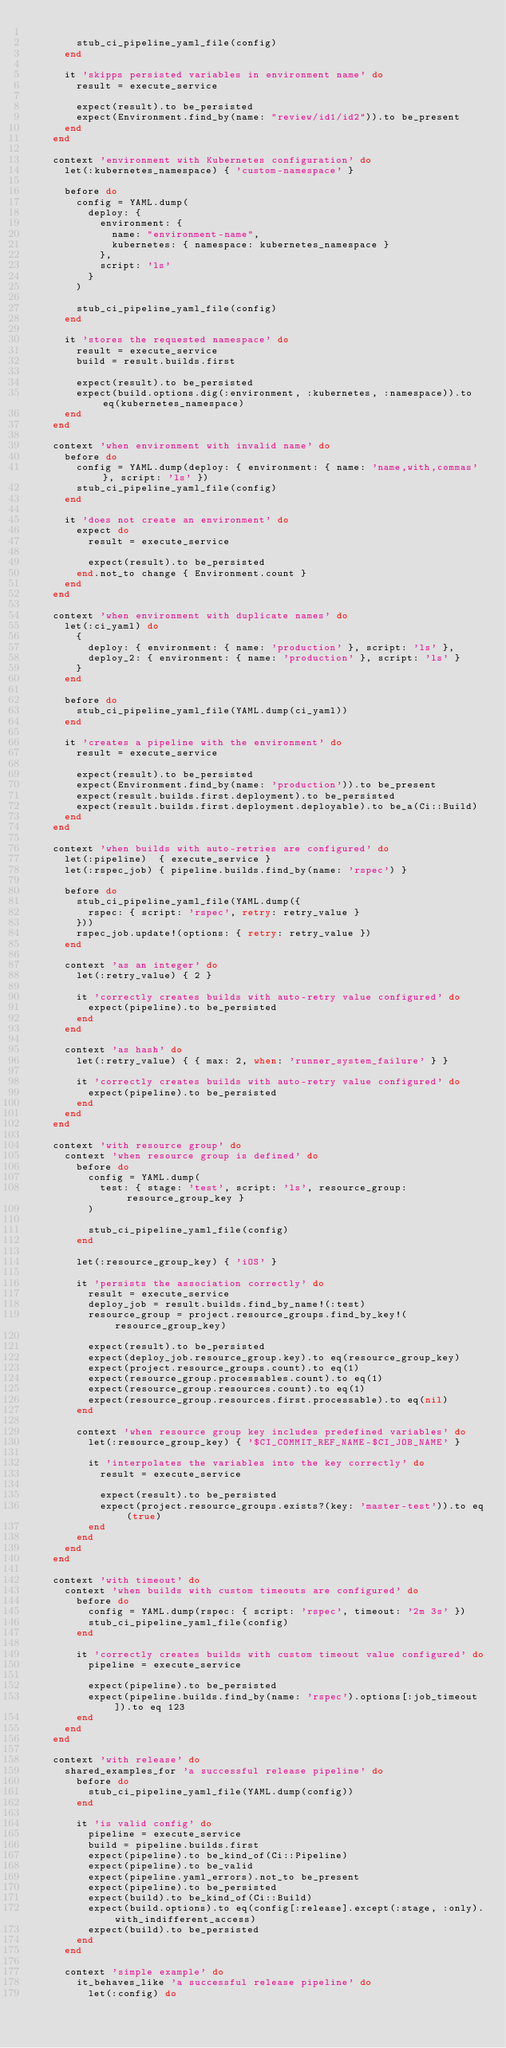<code> <loc_0><loc_0><loc_500><loc_500><_Ruby_>
        stub_ci_pipeline_yaml_file(config)
      end

      it 'skipps persisted variables in environment name' do
        result = execute_service

        expect(result).to be_persisted
        expect(Environment.find_by(name: "review/id1/id2")).to be_present
      end
    end

    context 'environment with Kubernetes configuration' do
      let(:kubernetes_namespace) { 'custom-namespace' }

      before do
        config = YAML.dump(
          deploy: {
            environment: {
              name: "environment-name",
              kubernetes: { namespace: kubernetes_namespace }
            },
            script: 'ls'
          }
        )

        stub_ci_pipeline_yaml_file(config)
      end

      it 'stores the requested namespace' do
        result = execute_service
        build = result.builds.first

        expect(result).to be_persisted
        expect(build.options.dig(:environment, :kubernetes, :namespace)).to eq(kubernetes_namespace)
      end
    end

    context 'when environment with invalid name' do
      before do
        config = YAML.dump(deploy: { environment: { name: 'name,with,commas' }, script: 'ls' })
        stub_ci_pipeline_yaml_file(config)
      end

      it 'does not create an environment' do
        expect do
          result = execute_service

          expect(result).to be_persisted
        end.not_to change { Environment.count }
      end
    end

    context 'when environment with duplicate names' do
      let(:ci_yaml) do
        {
          deploy: { environment: { name: 'production' }, script: 'ls' },
          deploy_2: { environment: { name: 'production' }, script: 'ls' }
        }
      end

      before do
        stub_ci_pipeline_yaml_file(YAML.dump(ci_yaml))
      end

      it 'creates a pipeline with the environment' do
        result = execute_service

        expect(result).to be_persisted
        expect(Environment.find_by(name: 'production')).to be_present
        expect(result.builds.first.deployment).to be_persisted
        expect(result.builds.first.deployment.deployable).to be_a(Ci::Build)
      end
    end

    context 'when builds with auto-retries are configured' do
      let(:pipeline)  { execute_service }
      let(:rspec_job) { pipeline.builds.find_by(name: 'rspec') }

      before do
        stub_ci_pipeline_yaml_file(YAML.dump({
          rspec: { script: 'rspec', retry: retry_value }
        }))
        rspec_job.update!(options: { retry: retry_value })
      end

      context 'as an integer' do
        let(:retry_value) { 2 }

        it 'correctly creates builds with auto-retry value configured' do
          expect(pipeline).to be_persisted
        end
      end

      context 'as hash' do
        let(:retry_value) { { max: 2, when: 'runner_system_failure' } }

        it 'correctly creates builds with auto-retry value configured' do
          expect(pipeline).to be_persisted
        end
      end
    end

    context 'with resource group' do
      context 'when resource group is defined' do
        before do
          config = YAML.dump(
            test: { stage: 'test', script: 'ls', resource_group: resource_group_key }
          )

          stub_ci_pipeline_yaml_file(config)
        end

        let(:resource_group_key) { 'iOS' }

        it 'persists the association correctly' do
          result = execute_service
          deploy_job = result.builds.find_by_name!(:test)
          resource_group = project.resource_groups.find_by_key!(resource_group_key)

          expect(result).to be_persisted
          expect(deploy_job.resource_group.key).to eq(resource_group_key)
          expect(project.resource_groups.count).to eq(1)
          expect(resource_group.processables.count).to eq(1)
          expect(resource_group.resources.count).to eq(1)
          expect(resource_group.resources.first.processable).to eq(nil)
        end

        context 'when resource group key includes predefined variables' do
          let(:resource_group_key) { '$CI_COMMIT_REF_NAME-$CI_JOB_NAME' }

          it 'interpolates the variables into the key correctly' do
            result = execute_service

            expect(result).to be_persisted
            expect(project.resource_groups.exists?(key: 'master-test')).to eq(true)
          end
        end
      end
    end

    context 'with timeout' do
      context 'when builds with custom timeouts are configured' do
        before do
          config = YAML.dump(rspec: { script: 'rspec', timeout: '2m 3s' })
          stub_ci_pipeline_yaml_file(config)
        end

        it 'correctly creates builds with custom timeout value configured' do
          pipeline = execute_service

          expect(pipeline).to be_persisted
          expect(pipeline.builds.find_by(name: 'rspec').options[:job_timeout]).to eq 123
        end
      end
    end

    context 'with release' do
      shared_examples_for 'a successful release pipeline' do
        before do
          stub_ci_pipeline_yaml_file(YAML.dump(config))
        end

        it 'is valid config' do
          pipeline = execute_service
          build = pipeline.builds.first
          expect(pipeline).to be_kind_of(Ci::Pipeline)
          expect(pipeline).to be_valid
          expect(pipeline.yaml_errors).not_to be_present
          expect(pipeline).to be_persisted
          expect(build).to be_kind_of(Ci::Build)
          expect(build.options).to eq(config[:release].except(:stage, :only).with_indifferent_access)
          expect(build).to be_persisted
        end
      end

      context 'simple example' do
        it_behaves_like 'a successful release pipeline' do
          let(:config) do</code> 